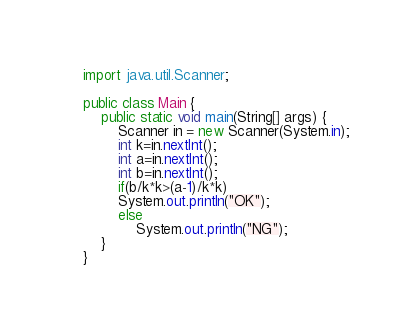<code> <loc_0><loc_0><loc_500><loc_500><_Java_>import java.util.Scanner;

public class Main {
    public static void main(String[] args) {
        Scanner in = new Scanner(System.in);
        int k=in.nextInt();
        int a=in.nextInt();
        int b=in.nextInt();
        if(b/k*k>(a-1)/k*k)
        System.out.println("OK");
        else
            System.out.println("NG");
    }
}
</code> 